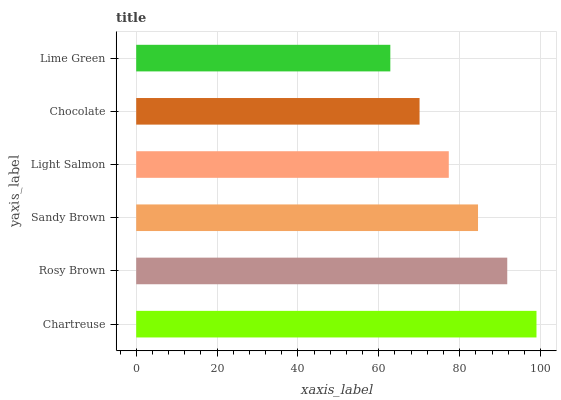Is Lime Green the minimum?
Answer yes or no. Yes. Is Chartreuse the maximum?
Answer yes or no. Yes. Is Rosy Brown the minimum?
Answer yes or no. No. Is Rosy Brown the maximum?
Answer yes or no. No. Is Chartreuse greater than Rosy Brown?
Answer yes or no. Yes. Is Rosy Brown less than Chartreuse?
Answer yes or no. Yes. Is Rosy Brown greater than Chartreuse?
Answer yes or no. No. Is Chartreuse less than Rosy Brown?
Answer yes or no. No. Is Sandy Brown the high median?
Answer yes or no. Yes. Is Light Salmon the low median?
Answer yes or no. Yes. Is Chocolate the high median?
Answer yes or no. No. Is Sandy Brown the low median?
Answer yes or no. No. 